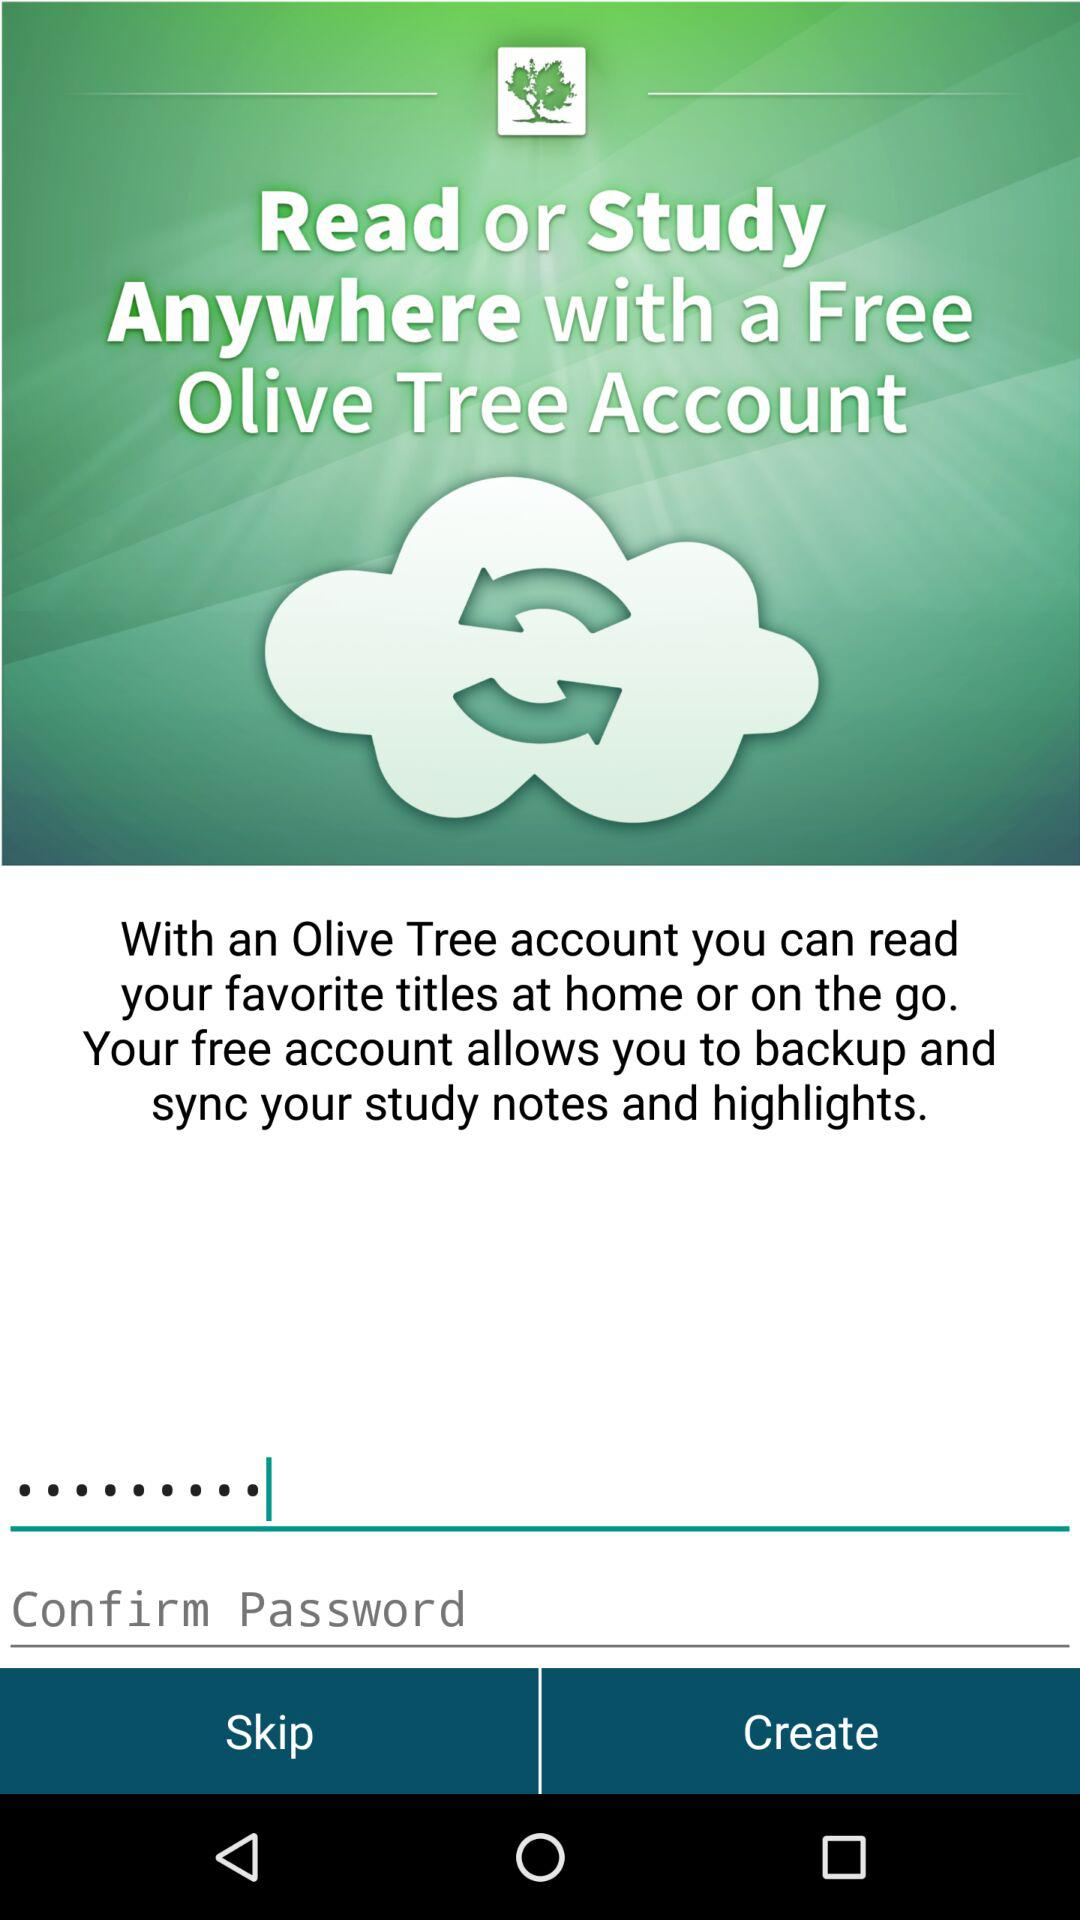What can we do for free with an Olive Tree account? You can read and write anywhere for free with an Olive Tree account. 